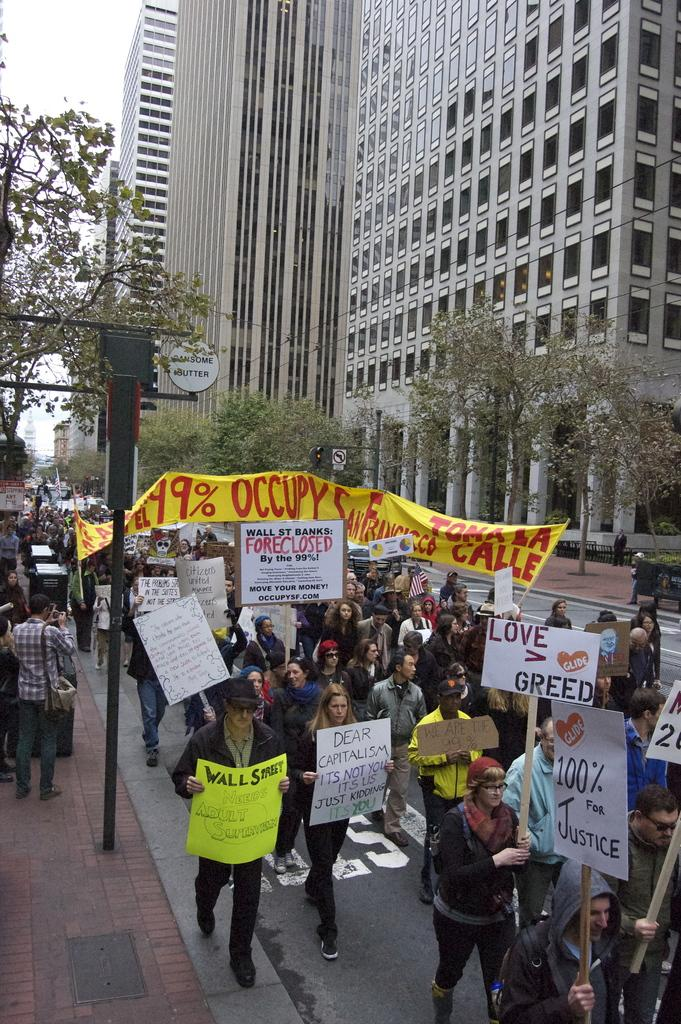How many people are in the image? There is a group of people in the image, but the exact number cannot be determined from the provided facts. What are some people doing in the image? Some people are holding placards in the image. What can be seen in the image besides the people and placards? There is a pole, trees, sign boards, and buildings visible in the background of the image. What type of butter is being used to grease the pole in the image? There is no butter or pole-greasing activity present in the image. What drink is being shared among the group of people in the image? There is no drink visible in the image. 